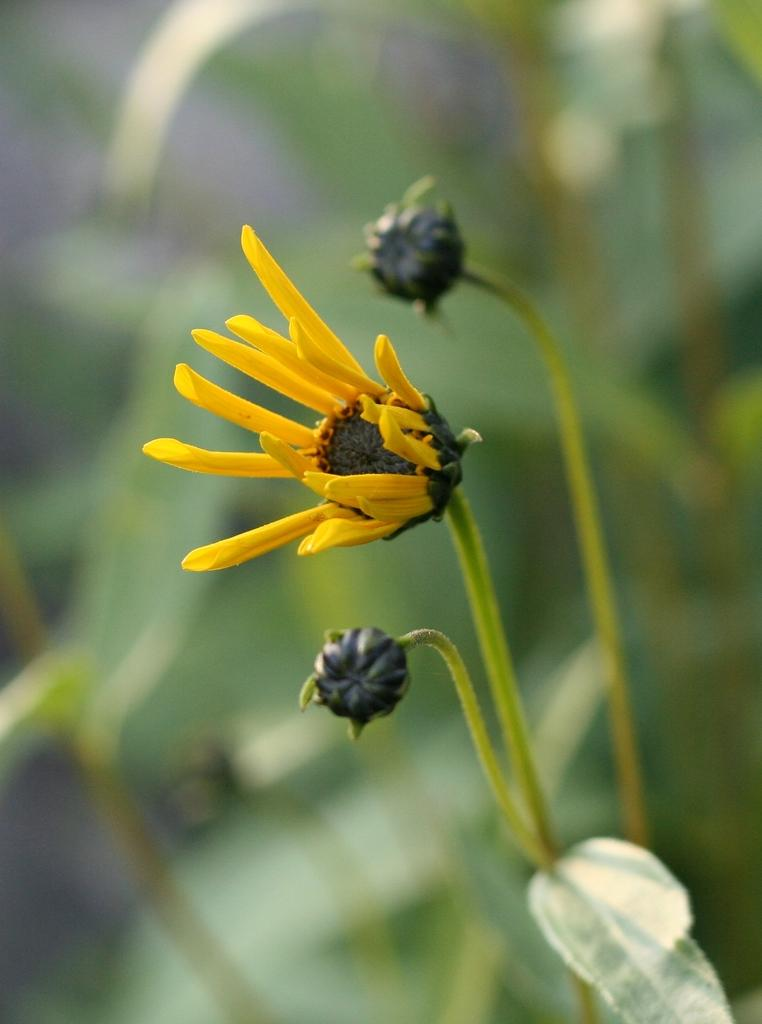What type of flower is present in the image? There is a yellow flower in the image. Are there any unopened flowers in the image? Yes, there are two buds in the image. What type of crime is being committed in the image? There is no crime present in the image; it features a yellow flower and two buds. Can you describe the man in the image? There is no man present in the image. 